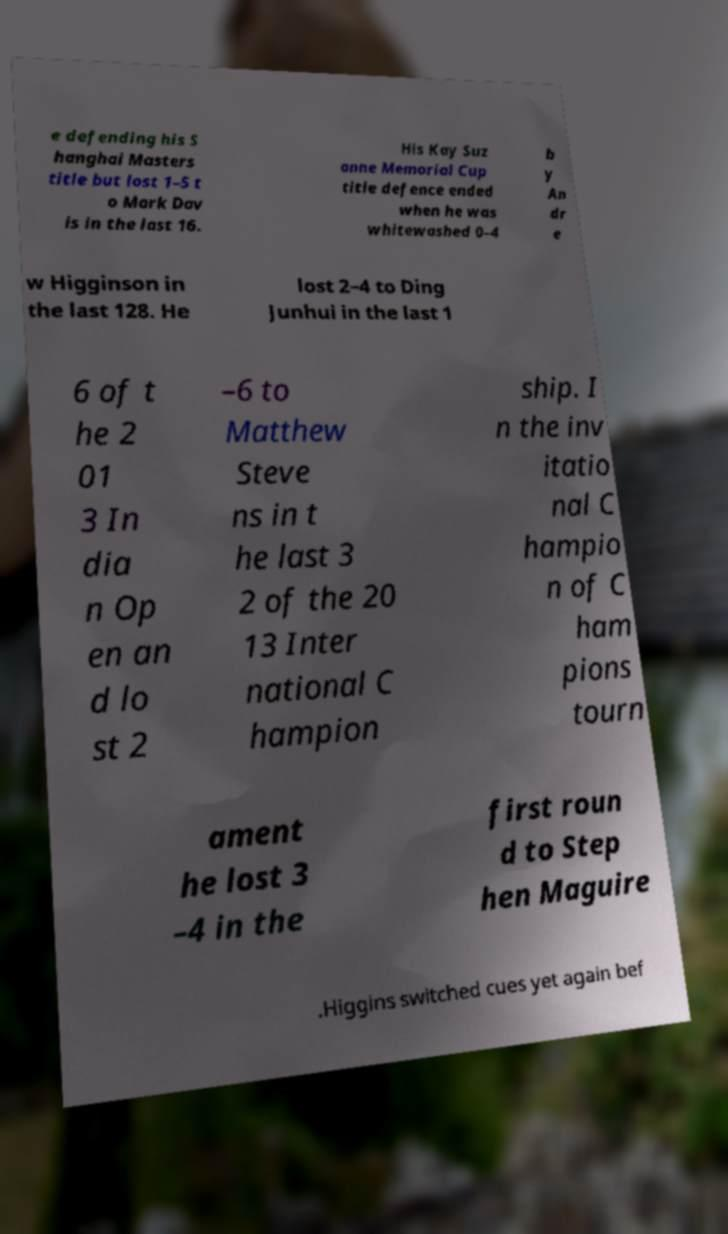Can you accurately transcribe the text from the provided image for me? e defending his S hanghai Masters title but lost 1–5 t o Mark Dav is in the last 16. His Kay Suz anne Memorial Cup title defence ended when he was whitewashed 0–4 b y An dr e w Higginson in the last 128. He lost 2–4 to Ding Junhui in the last 1 6 of t he 2 01 3 In dia n Op en an d lo st 2 –6 to Matthew Steve ns in t he last 3 2 of the 20 13 Inter national C hampion ship. I n the inv itatio nal C hampio n of C ham pions tourn ament he lost 3 –4 in the first roun d to Step hen Maguire .Higgins switched cues yet again bef 